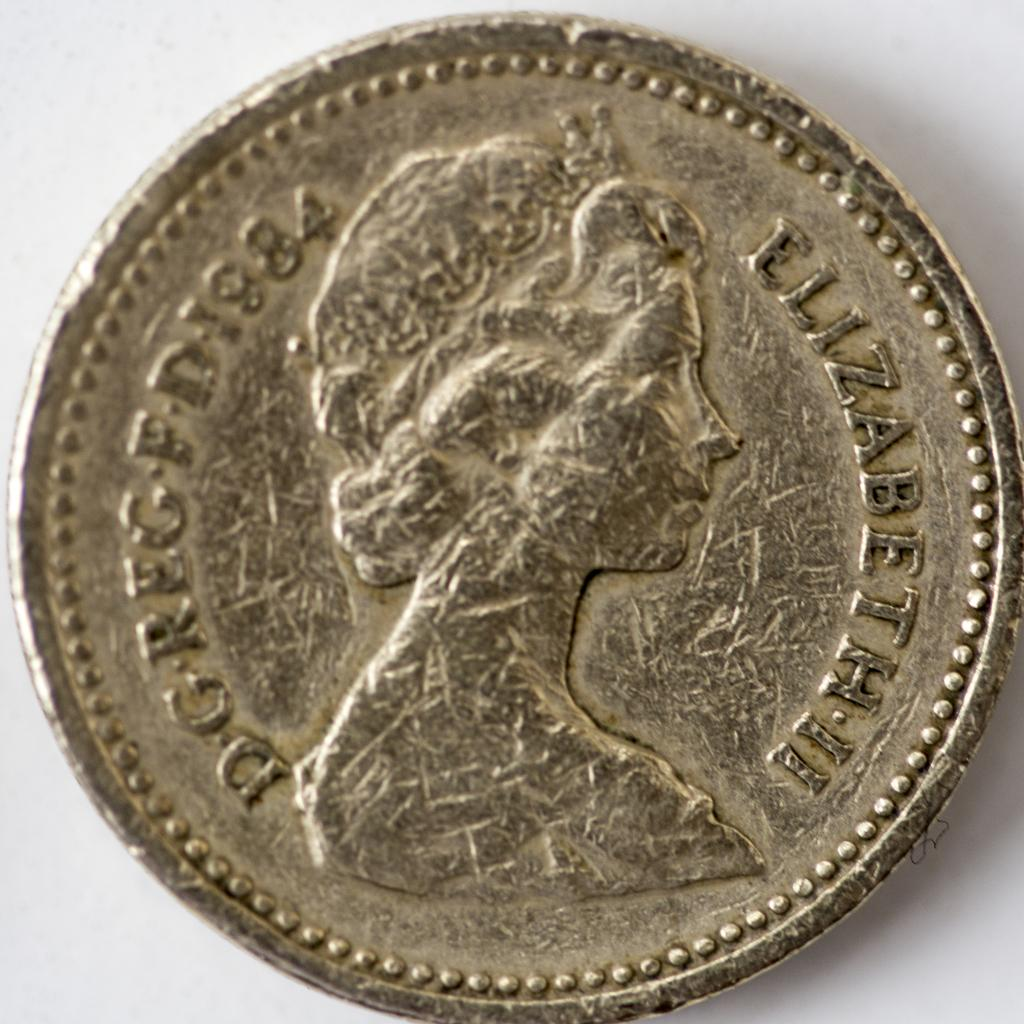<image>
Offer a succinct explanation of the picture presented. A coin with a woman on it with the word Elizabeth II is shown. 